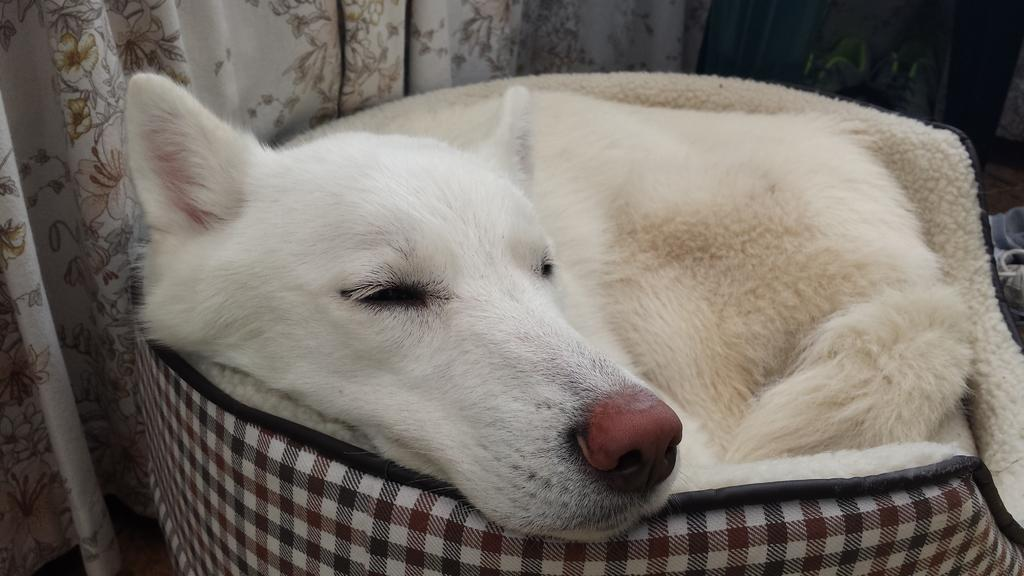What type of animal is present in the image? There is a white-colored dog in the image. What other object can be seen in the image? There is a multi-colored cloth in the image. What color is the curtain visible in the background of the image? There is a cream-colored curtain visible in the background of the image. Can you hear the dog whistling in the image? There is no indication of sound or whistling in the image; it is a still photograph. 